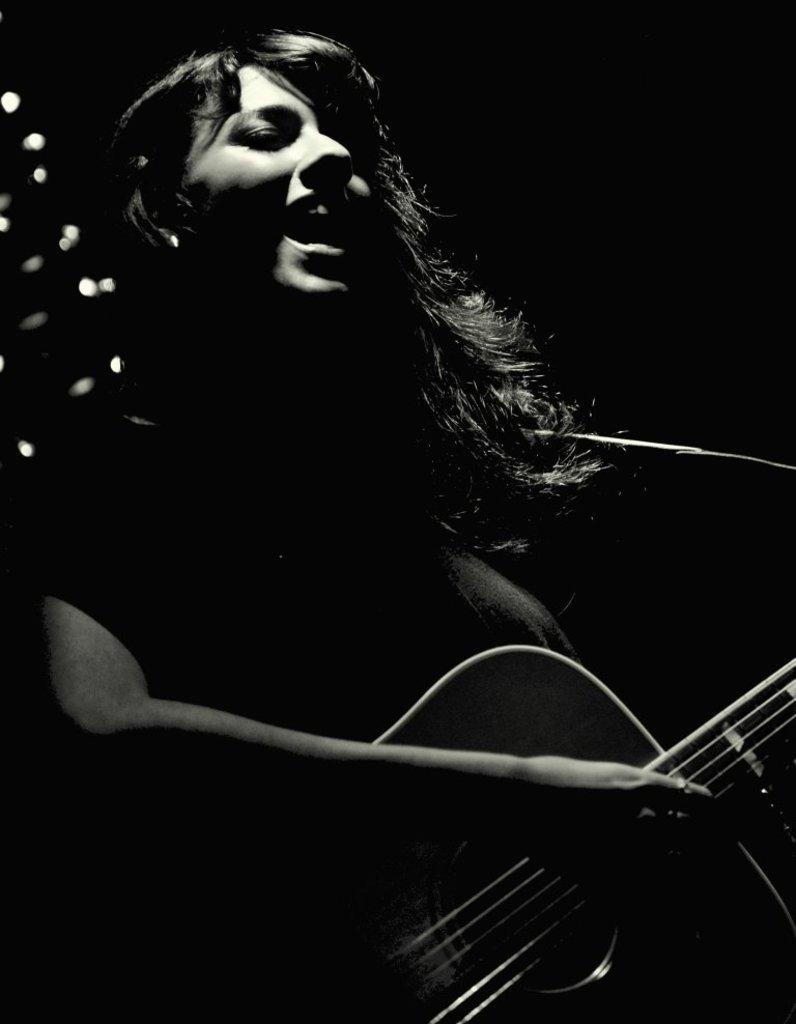Who is the main subject in the image? There is a girl in the image. What is the girl doing in the image? The girl is singing and playing a guitar. How many holes are visible in the girl's foot in the image? There are no holes visible in the girl's foot in the image, as the girl is not shown with her foot exposed. 